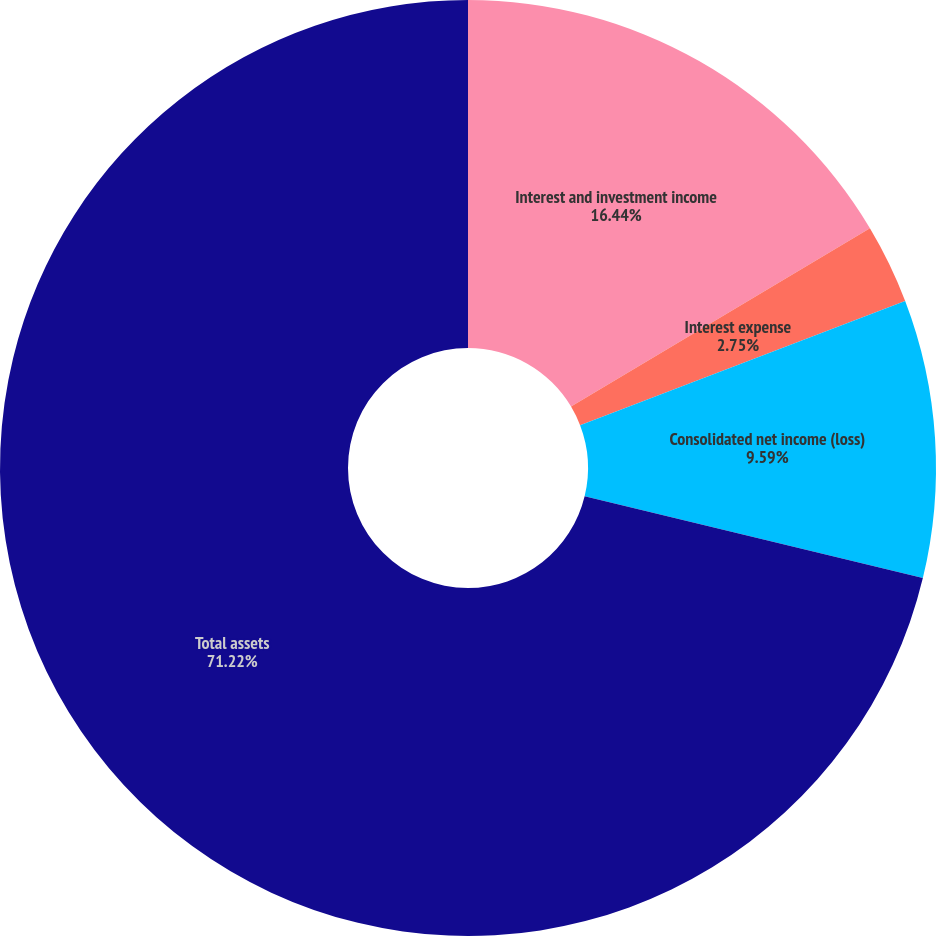<chart> <loc_0><loc_0><loc_500><loc_500><pie_chart><fcel>Interest and investment income<fcel>Interest expense<fcel>Consolidated net income (loss)<fcel>Total assets<nl><fcel>16.44%<fcel>2.75%<fcel>9.59%<fcel>71.22%<nl></chart> 